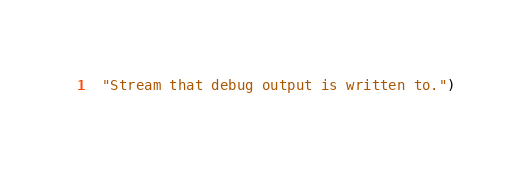<code> <loc_0><loc_0><loc_500><loc_500><_Lisp_>  "Stream that debug output is written to.")
</code> 